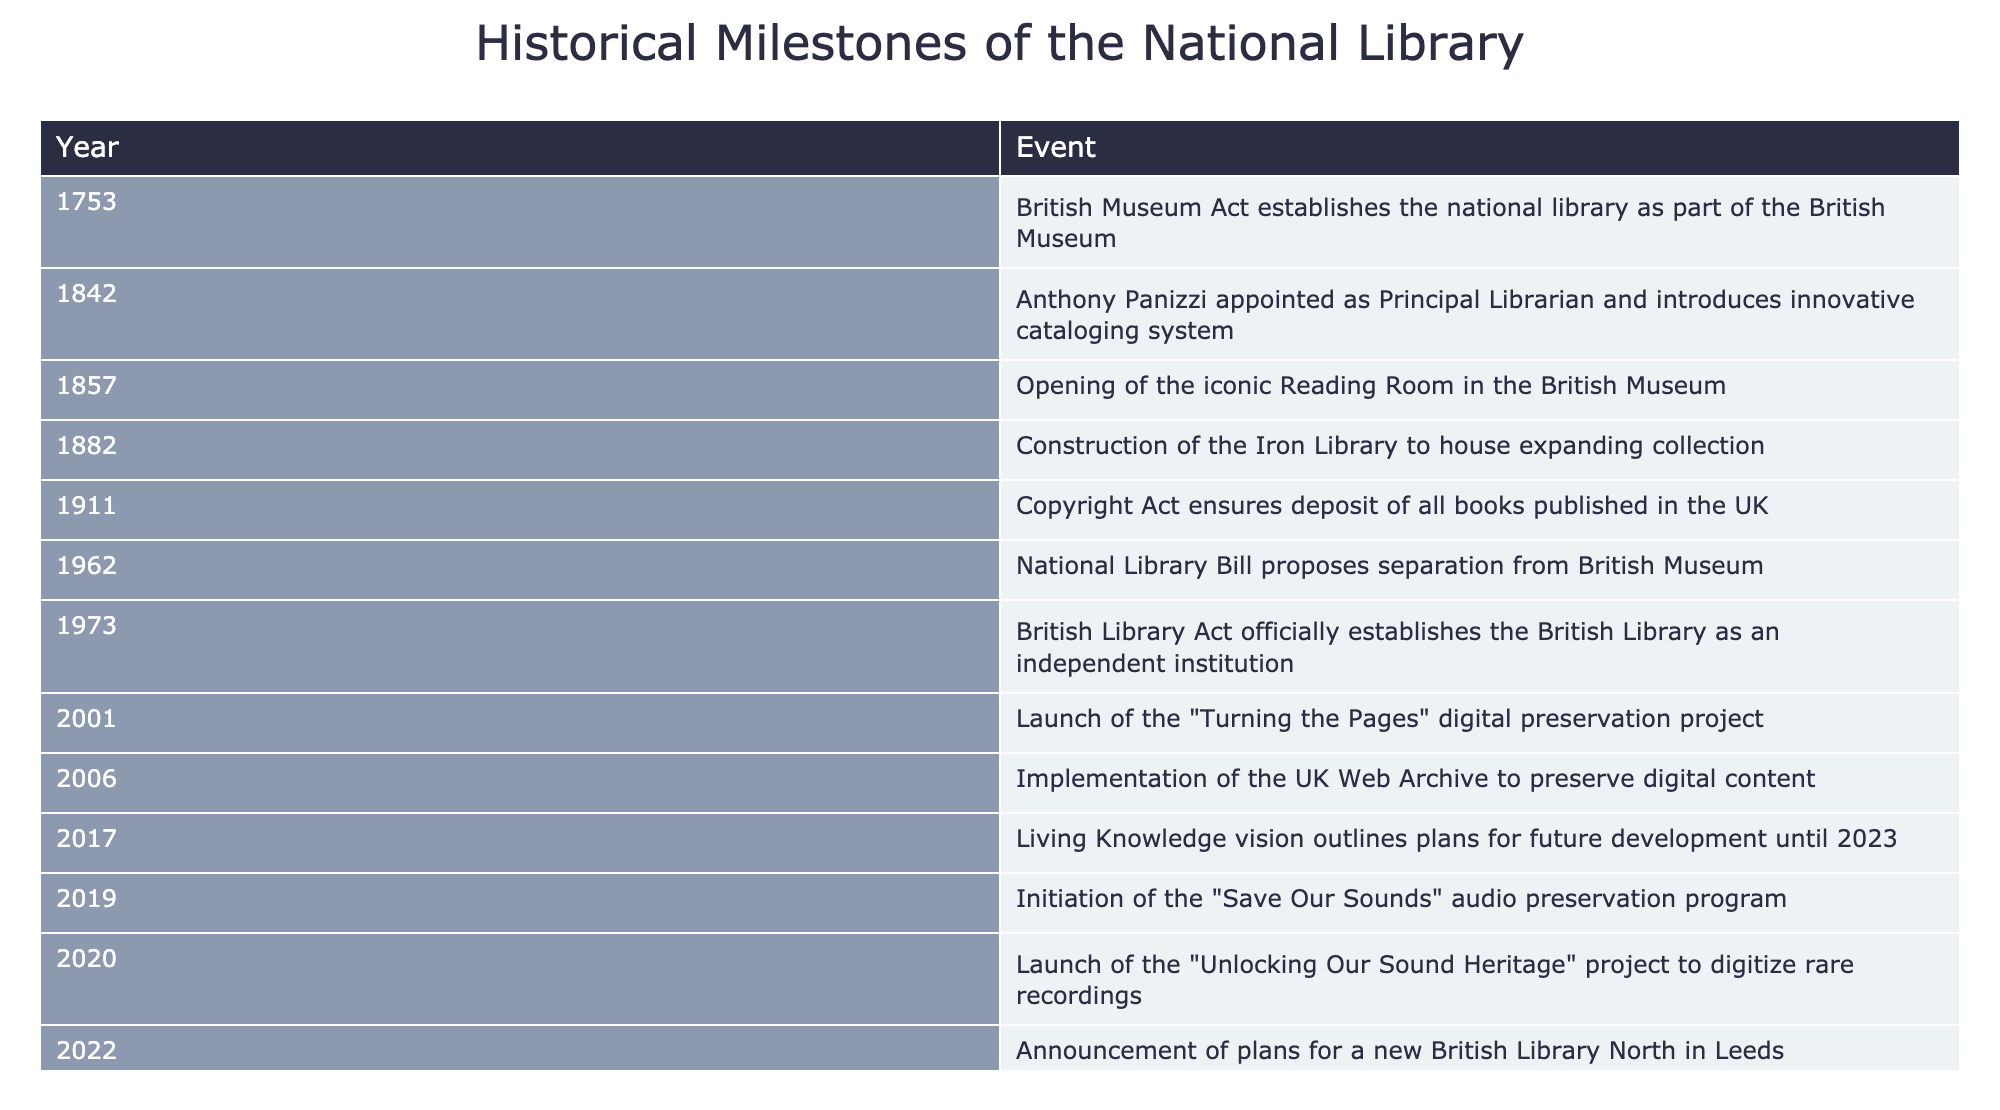What event marks the official establishment of the British Library as an independent institution? According to the table, the British Library Act in 1973 marks the official establishment of the British Library as an independent institution.
Answer: British Library Act (1973) Which event occurred first: the opening of the Reading Room or the construction of the Iron Library? The table shows that the Reading Room opened in 1857, while the Iron Library was constructed in 1882. Since 1857 is earlier than 1882, the Reading Room opened first.
Answer: The Reading Room How many years passed between the British Museum Act and the implementation of the Copyright Act? The British Museum Act was established in 1753 and the Copyright Act was passed in 1911. To find the difference, subtract 1753 from 1911, which gives 1911 - 1753 = 158 years.
Answer: 158 years Was the launch of the “Turning the Pages” digital preservation project in 2001 a milestone for digital preservation? The table indicates that the “Turning the Pages” project was launched in 2001, which aligns with the goal of digital preservation, thus confirming it is a milestone for that purpose.
Answer: Yes How many significant events happened between the years 1962 and 2020? The table lists three significant events between 1962 and 2020: the British Library Act in 1973, the launch of the audio preservation program in 2019, and the "Unlocking Our Sound Heritage" project in 2020. We can count these events: 1973, 2019, and 2020, yielding a total of 3 events.
Answer: 3 events What is the most recent plan mentioned in the table related to the future development of the national library? According to the table, the most recent event related to future development is the Living Knowledge vision, which outlines plans for development until 2023. The date for this event is 2017, as it shows the foresight for the library.
Answer: Living Knowledge vision (2017) Is there evidence of efforts to preserve audio content in the national library before 2020? Yes, the table shows that the “Save Our Sounds” audio preservation program was initiated in 2019, indicating an effort to preserve audio content before 2020.
Answer: Yes What event ensured the deposit of all books published in the UK? The Copyright Act in 1911, as indicated in the table, is the event that ensured the deposit of all books published in the UK.
Answer: Copyright Act (1911) 